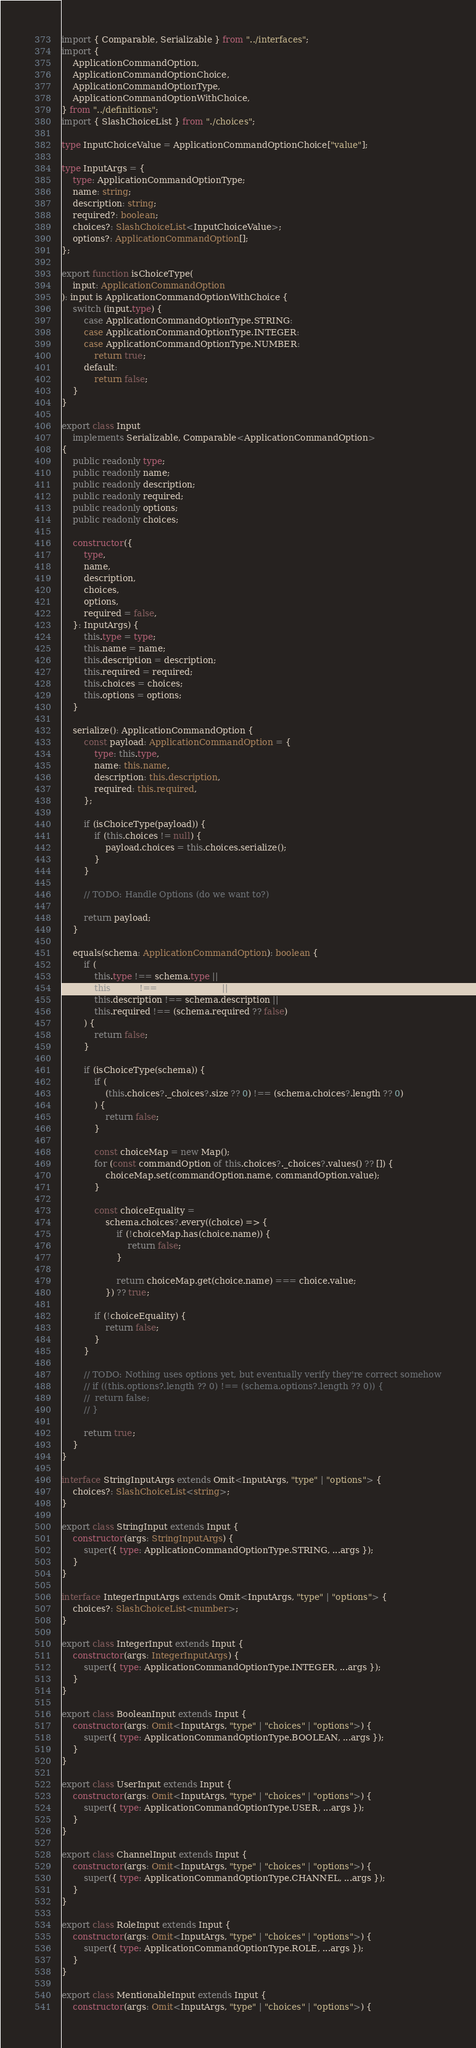Convert code to text. <code><loc_0><loc_0><loc_500><loc_500><_TypeScript_>import { Comparable, Serializable } from "../interfaces";
import {
	ApplicationCommandOption,
	ApplicationCommandOptionChoice,
	ApplicationCommandOptionType,
	ApplicationCommandOptionWithChoice,
} from "../definitions";
import { SlashChoiceList } from "./choices";

type InputChoiceValue = ApplicationCommandOptionChoice["value"];

type InputArgs = {
	type: ApplicationCommandOptionType;
	name: string;
	description: string;
	required?: boolean;
	choices?: SlashChoiceList<InputChoiceValue>;
	options?: ApplicationCommandOption[];
};

export function isChoiceType(
	input: ApplicationCommandOption
): input is ApplicationCommandOptionWithChoice {
	switch (input.type) {
		case ApplicationCommandOptionType.STRING:
		case ApplicationCommandOptionType.INTEGER:
		case ApplicationCommandOptionType.NUMBER:
			return true;
		default:
			return false;
	}
}

export class Input
	implements Serializable, Comparable<ApplicationCommandOption>
{
	public readonly type;
	public readonly name;
	public readonly description;
	public readonly required;
	public readonly options;
	public readonly choices;

	constructor({
		type,
		name,
		description,
		choices,
		options,
		required = false,
	}: InputArgs) {
		this.type = type;
		this.name = name;
		this.description = description;
		this.required = required;
		this.choices = choices;
		this.options = options;
	}

	serialize(): ApplicationCommandOption {
		const payload: ApplicationCommandOption = {
			type: this.type,
			name: this.name,
			description: this.description,
			required: this.required,
		};

		if (isChoiceType(payload)) {
			if (this.choices != null) {
				payload.choices = this.choices.serialize();
			}
		}

		// TODO: Handle Options (do we want to?)

		return payload;
	}

	equals(schema: ApplicationCommandOption): boolean {
		if (
			this.type !== schema.type ||
			this.name !== schema.name ||
			this.description !== schema.description ||
			this.required !== (schema.required ?? false)
		) {
			return false;
		}

		if (isChoiceType(schema)) {
			if (
				(this.choices?._choices?.size ?? 0) !== (schema.choices?.length ?? 0)
			) {
				return false;
			}

			const choiceMap = new Map();
			for (const commandOption of this.choices?._choices?.values() ?? []) {
				choiceMap.set(commandOption.name, commandOption.value);
			}

			const choiceEquality =
				schema.choices?.every((choice) => {
					if (!choiceMap.has(choice.name)) {
						return false;
					}

					return choiceMap.get(choice.name) === choice.value;
				}) ?? true;

			if (!choiceEquality) {
				return false;
			}
		}

		// TODO: Nothing uses options yet, but eventually verify they're correct somehow
		// if ((this.options?.length ?? 0) !== (schema.options?.length ?? 0)) {
		// 	return false;
		// }

		return true;
	}
}

interface StringInputArgs extends Omit<InputArgs, "type" | "options"> {
	choices?: SlashChoiceList<string>;
}

export class StringInput extends Input {
	constructor(args: StringInputArgs) {
		super({ type: ApplicationCommandOptionType.STRING, ...args });
	}
}

interface IntegerInputArgs extends Omit<InputArgs, "type" | "options"> {
	choices?: SlashChoiceList<number>;
}

export class IntegerInput extends Input {
	constructor(args: IntegerInputArgs) {
		super({ type: ApplicationCommandOptionType.INTEGER, ...args });
	}
}

export class BooleanInput extends Input {
	constructor(args: Omit<InputArgs, "type" | "choices" | "options">) {
		super({ type: ApplicationCommandOptionType.BOOLEAN, ...args });
	}
}

export class UserInput extends Input {
	constructor(args: Omit<InputArgs, "type" | "choices" | "options">) {
		super({ type: ApplicationCommandOptionType.USER, ...args });
	}
}

export class ChannelInput extends Input {
	constructor(args: Omit<InputArgs, "type" | "choices" | "options">) {
		super({ type: ApplicationCommandOptionType.CHANNEL, ...args });
	}
}

export class RoleInput extends Input {
	constructor(args: Omit<InputArgs, "type" | "choices" | "options">) {
		super({ type: ApplicationCommandOptionType.ROLE, ...args });
	}
}

export class MentionableInput extends Input {
	constructor(args: Omit<InputArgs, "type" | "choices" | "options">) {</code> 